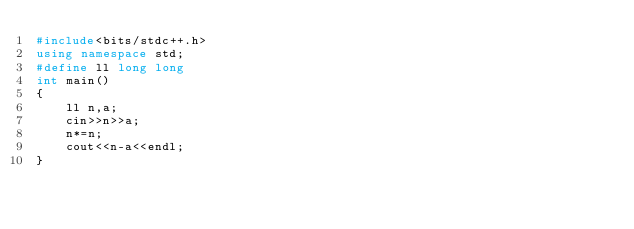<code> <loc_0><loc_0><loc_500><loc_500><_C++_>#include<bits/stdc++.h>
using namespace std;
#define ll long long
int main()
{
    ll n,a;
    cin>>n>>a;
    n*=n;
    cout<<n-a<<endl;
}
</code> 